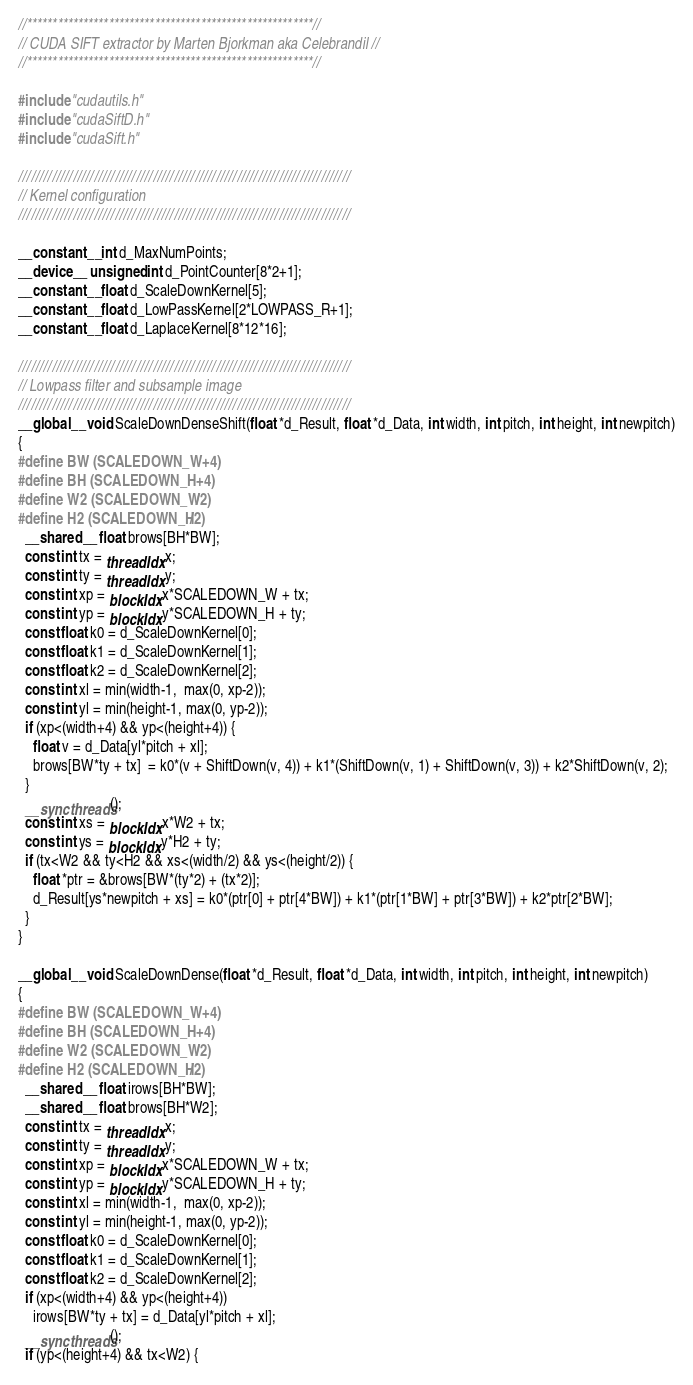<code> <loc_0><loc_0><loc_500><loc_500><_Cuda_>//********************************************************//
// CUDA SIFT extractor by Marten Bjorkman aka Celebrandil //
//********************************************************//  

#include "cudautils.h"
#include "cudaSiftD.h"
#include "cudaSift.h"

///////////////////////////////////////////////////////////////////////////////
// Kernel configuration
///////////////////////////////////////////////////////////////////////////////

__constant__ int d_MaxNumPoints;
__device__ unsigned int d_PointCounter[8*2+1];
__constant__ float d_ScaleDownKernel[5]; 
__constant__ float d_LowPassKernel[2*LOWPASS_R+1]; 
__constant__ float d_LaplaceKernel[8*12*16]; 

///////////////////////////////////////////////////////////////////////////////
// Lowpass filter and subsample image
///////////////////////////////////////////////////////////////////////////////
__global__ void ScaleDownDenseShift(float *d_Result, float *d_Data, int width, int pitch, int height, int newpitch)
{
#define BW (SCALEDOWN_W+4)
#define BH (SCALEDOWN_H+4)
#define W2 (SCALEDOWN_W/2)
#define H2 (SCALEDOWN_H/2)
  __shared__ float brows[BH*BW];
  const int tx = threadIdx.x;
  const int ty = threadIdx.y;
  const int xp = blockIdx.x*SCALEDOWN_W + tx;
  const int yp = blockIdx.y*SCALEDOWN_H + ty;
  const float k0 = d_ScaleDownKernel[0];
  const float k1 = d_ScaleDownKernel[1];
  const float k2 = d_ScaleDownKernel[2];
  const int xl = min(width-1,  max(0, xp-2));
  const int yl = min(height-1, max(0, yp-2));
  if (xp<(width+4) && yp<(height+4)) {
    float v = d_Data[yl*pitch + xl];
    brows[BW*ty + tx]  = k0*(v + ShiftDown(v, 4)) + k1*(ShiftDown(v, 1) + ShiftDown(v, 3)) + k2*ShiftDown(v, 2);
  }
  __syncthreads();
  const int xs = blockIdx.x*W2 + tx;
  const int ys = blockIdx.y*H2 + ty;
  if (tx<W2 && ty<H2 && xs<(width/2) && ys<(height/2)) {
    float *ptr = &brows[BW*(ty*2) + (tx*2)];
    d_Result[ys*newpitch + xs] = k0*(ptr[0] + ptr[4*BW]) + k1*(ptr[1*BW] + ptr[3*BW]) + k2*ptr[2*BW];
  } 
}

__global__ void ScaleDownDense(float *d_Result, float *d_Data, int width, int pitch, int height, int newpitch)
{
#define BW (SCALEDOWN_W+4)
#define BH (SCALEDOWN_H+4)
#define W2 (SCALEDOWN_W/2)
#define H2 (SCALEDOWN_H/2)
  __shared__ float irows[BH*BW]; 
  __shared__ float brows[BH*W2];
  const int tx = threadIdx.x;
  const int ty = threadIdx.y;
  const int xp = blockIdx.x*SCALEDOWN_W + tx;
  const int yp = blockIdx.y*SCALEDOWN_H + ty;
  const int xl = min(width-1,  max(0, xp-2));
  const int yl = min(height-1, max(0, yp-2));
  const float k0 = d_ScaleDownKernel[0];
  const float k1 = d_ScaleDownKernel[1];
  const float k2 = d_ScaleDownKernel[2];
  if (xp<(width+4) && yp<(height+4))
    irows[BW*ty + tx] = d_Data[yl*pitch + xl];
  __syncthreads();
  if (yp<(height+4) && tx<W2) {</code> 